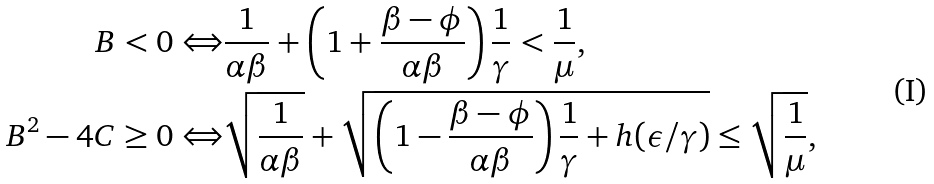<formula> <loc_0><loc_0><loc_500><loc_500>B < 0 \Leftrightarrow & \frac { 1 } { \alpha \beta } + \left ( 1 + \frac { \beta - \phi } { \alpha \beta } \right ) \frac { 1 } { \gamma } < \frac { 1 } { \mu } , \\ B ^ { 2 } - 4 C \geq 0 \Leftrightarrow & \sqrt { \frac { 1 } { \alpha \beta } } + \sqrt { \left ( 1 - \frac { \beta - \phi } { \alpha \beta } \right ) \frac { 1 } { \gamma } + h ( \epsilon / \gamma ) } \leq \sqrt { \frac { 1 } { \mu } } ,</formula> 